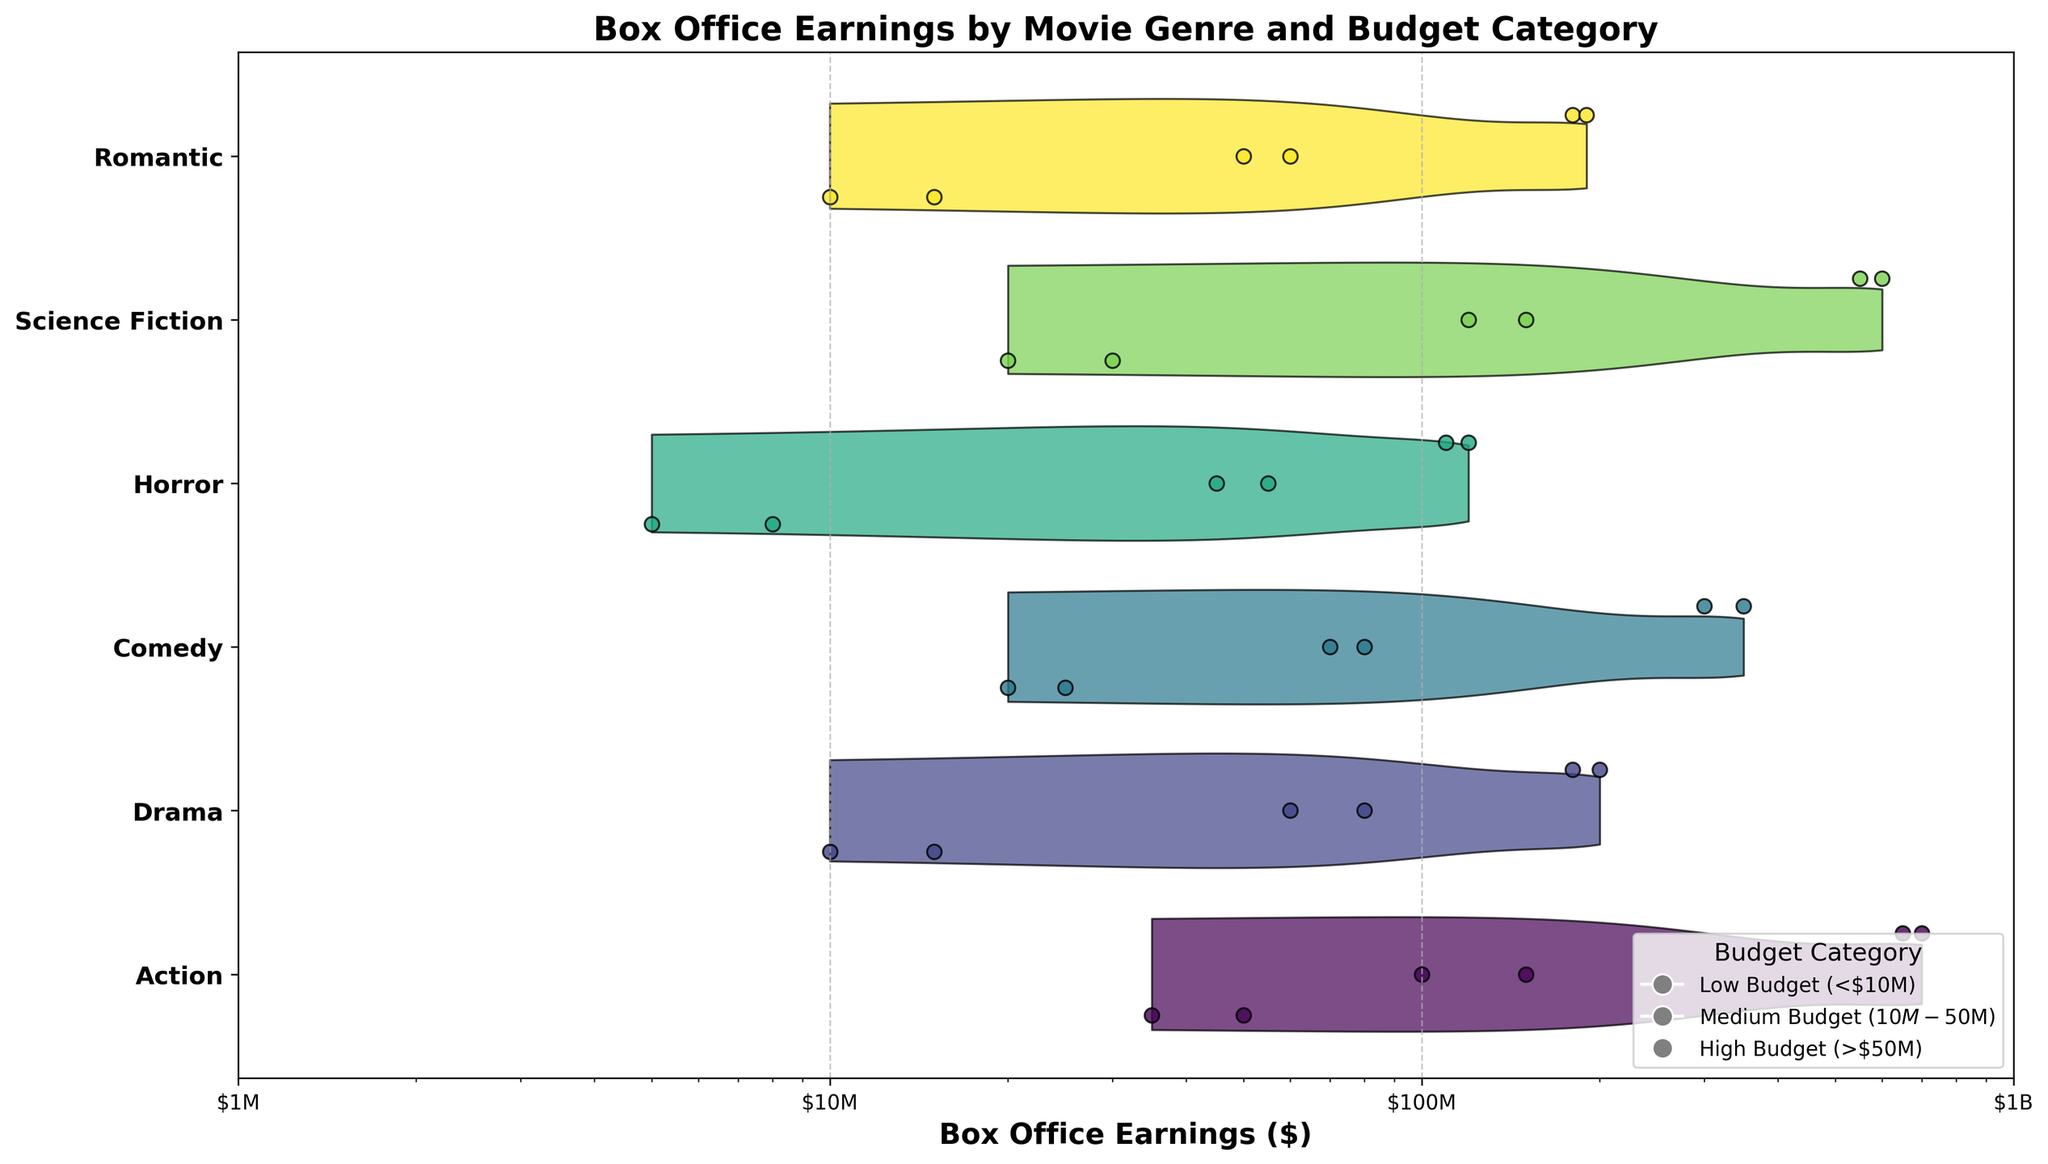What is the title of the figure? The title of the figure is displayed at the top. It provides a summary of what the figure represents.
Answer: Box Office Earnings by Movie Genre and Budget Category Which genre has the highest earnings in the high budget category? By looking at the data points for each genre within the high budget category, we see the highest values. For the Action genre, the earnings reach up to $700M, which is higher than other genres.
Answer: Action How do the box office earnings compare between low and medium budget categories for Drama? We compare the data points for the Drama genre across the low and medium budget categories. Low budget earnings are around $10M-$15M, while medium budget earnings are around $60M-$80M.
Answer: The medium budget category has higher earnings What is the average box office earning for Comedy films in the high budget category? To calculate the average for Comedy in the high budget category, sum the earnings (300M + 350M) and divide by the number of data points. (300M + 350M) / 2 = 325M.
Answer: 325M Which budget category shows the largest range of box office earnings for Science Fiction films? By observing the spread of data points within each category for Science Fiction, the high budget category varies from $550M to $600M, while the other categories have a smaller range.
Answer: High Budget (>$50M) Are there any signs of an outlier in the low budget category for any genre? We look for data points that are significantly different from the rest within the low budget category for each genre. No outliers are evident as all low budget points cluster close together.
Answer: No Which genre has the least variation in box office earnings within the medium budget category? Assessing the spread of data points within the medium budget category for each genre reveals that Drama has box office earnings tightly clustered around $60M-$80M.
Answer: Drama How are the box office earnings distributed for Horror films across different budget categories? Horror film earnings distribute as follows: low budget category around $5M-$8M, medium budget category around $45M-$55M, and high budget category around $110M-$120M. Each category shows distinct clustering.
Answer: Distinct clusters in each category Which budget category has Science Fiction films with earnings close to or above $100M? By examining the data for Science Fiction, the medium budget ($10M-$50M) and high budget (>$50M) categories have values around and above $100M.
Answer: Medium and High Budget What does the y-axis represent in the figure? The y-axis labels indicate the different genres of movies. It helps to segregate the earnings visually based on the movie genre.
Answer: Movie genres 